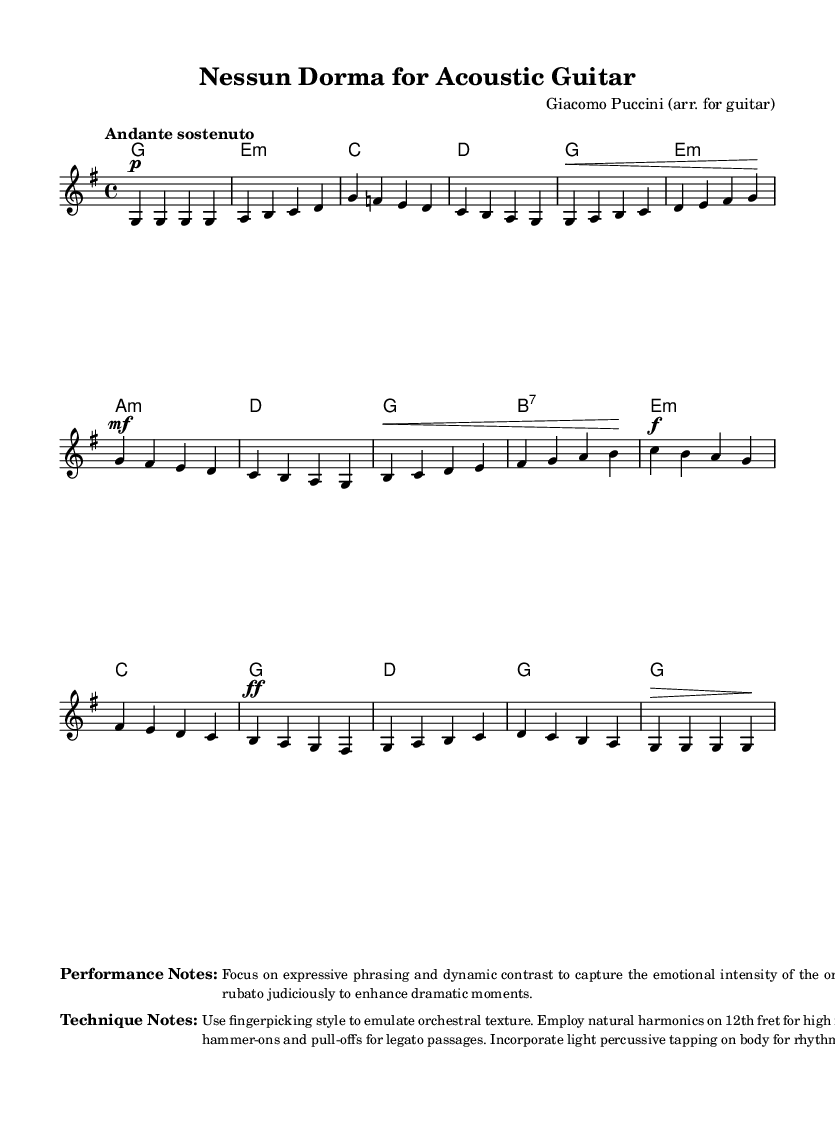What is the key signature of this music? The key signature indicates that there is one sharp (F#), which defines the key of G major.
Answer: G major What is the time signature of this music? The time signature indicated in the sheet music is shown at the beginning as a fraction, which tells us how many beats are in each measure; it is 4/4.
Answer: 4/4 What is the tempo marking of this piece? The tempo marking is provided at the beginning of the sheet music to indicate the speed; it states "Andante sostenuto," which means a moderately slow tempo.
Answer: Andante sostenuto How many measures are in the first verse? Counting the measures in the verse section of the sheet music, the first verse consists of 4 measures.
Answer: 4 What dynamic markings are used in the climax section? The dynamic markings in the climax section show the intensity, indicated as "ff" (forte forte) and a decrescendo as ">" before the last note.
Answer: ff What performance technique is recommended for the guitar? The performance notes emphasize using fingerpicking style to emulate orchestral texture, indicating a specific technique for playing the piece expressively.
Answer: Fingerpicking What is the last note of the piece? The last note is indicated at the end of the last measure in the piece and is a G note, determining how the piece concludes.
Answer: G 